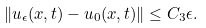Convert formula to latex. <formula><loc_0><loc_0><loc_500><loc_500>\left \| u _ { \epsilon } ( x , t ) - u _ { 0 } ( x , t ) \right \| \leq C _ { 3 } \epsilon .</formula> 